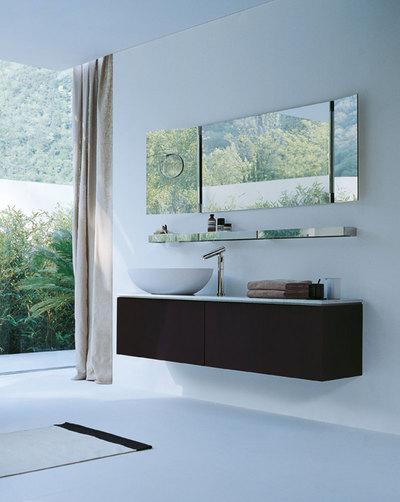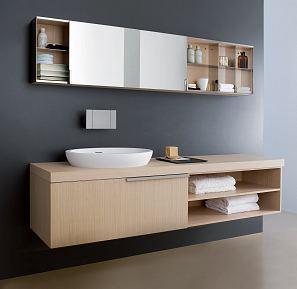The first image is the image on the left, the second image is the image on the right. Evaluate the accuracy of this statement regarding the images: "In one image, a wide box-like vanity attached to the wall has a white sink installed at one end, while the opposite end is open, showing towel storage.". Is it true? Answer yes or no. Yes. The first image is the image on the left, the second image is the image on the right. Analyze the images presented: Is the assertion "An image shows a wall-mounted beige vanity with opened shelf section containing stacks of white towels." valid? Answer yes or no. Yes. 